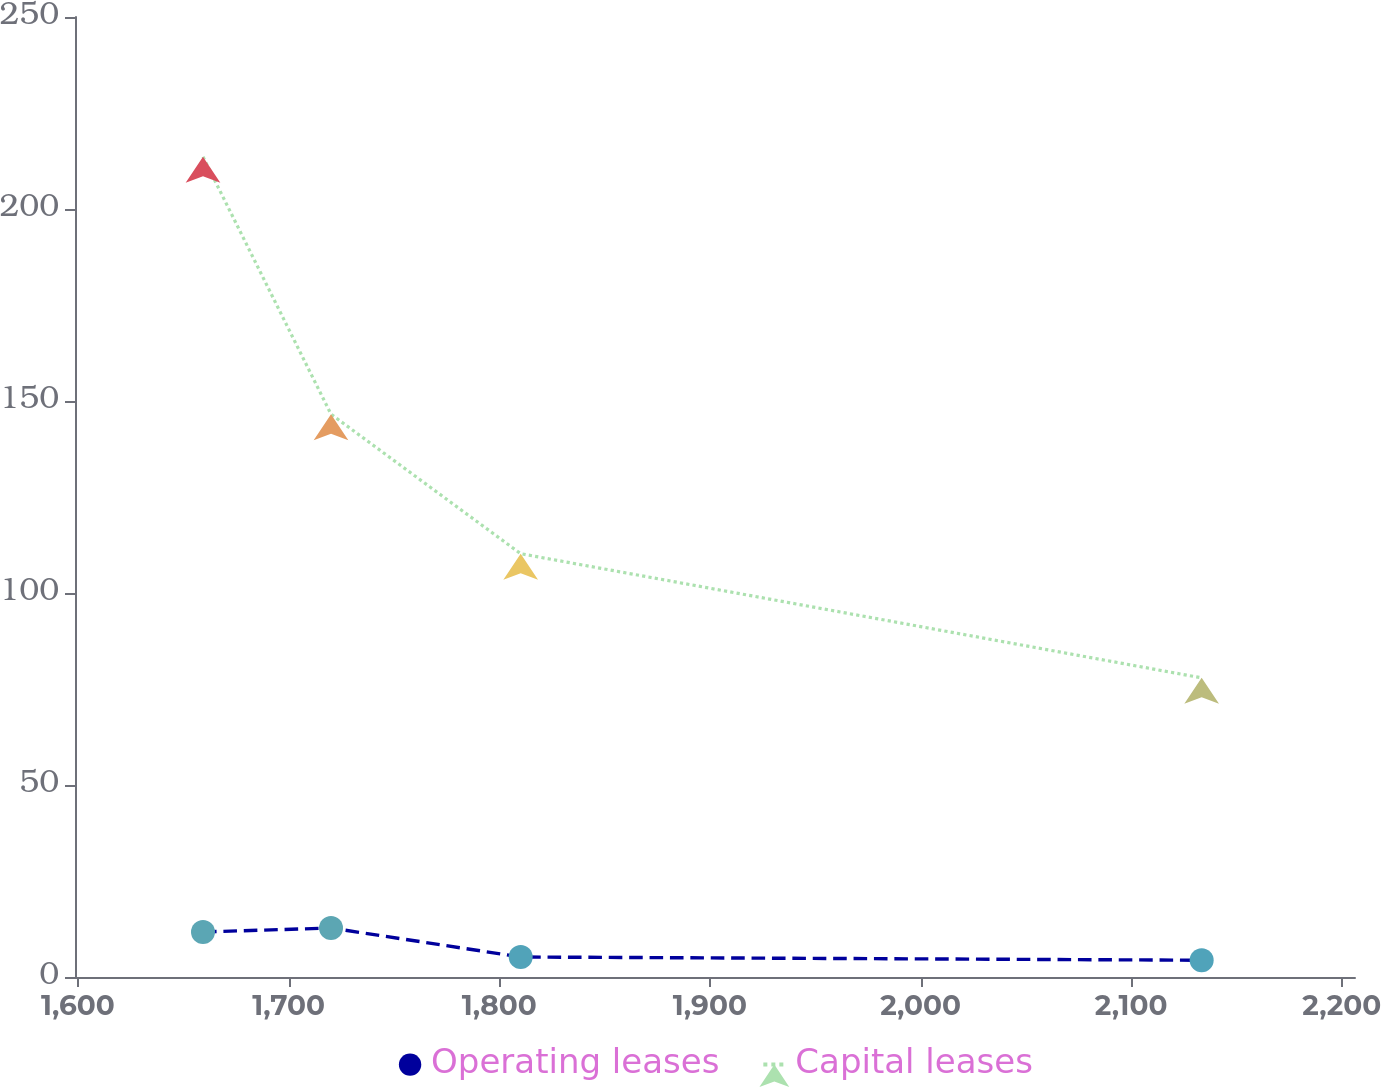<chart> <loc_0><loc_0><loc_500><loc_500><line_chart><ecel><fcel>Operating leases<fcel>Capital leases<nl><fcel>1659.36<fcel>11.73<fcel>213.6<nl><fcel>1720.13<fcel>12.75<fcel>146.56<nl><fcel>1810.18<fcel>5.21<fcel>110.23<nl><fcel>2133.46<fcel>4.37<fcel>77.9<nl><fcel>2267.02<fcel>6.05<fcel>58.65<nl></chart> 